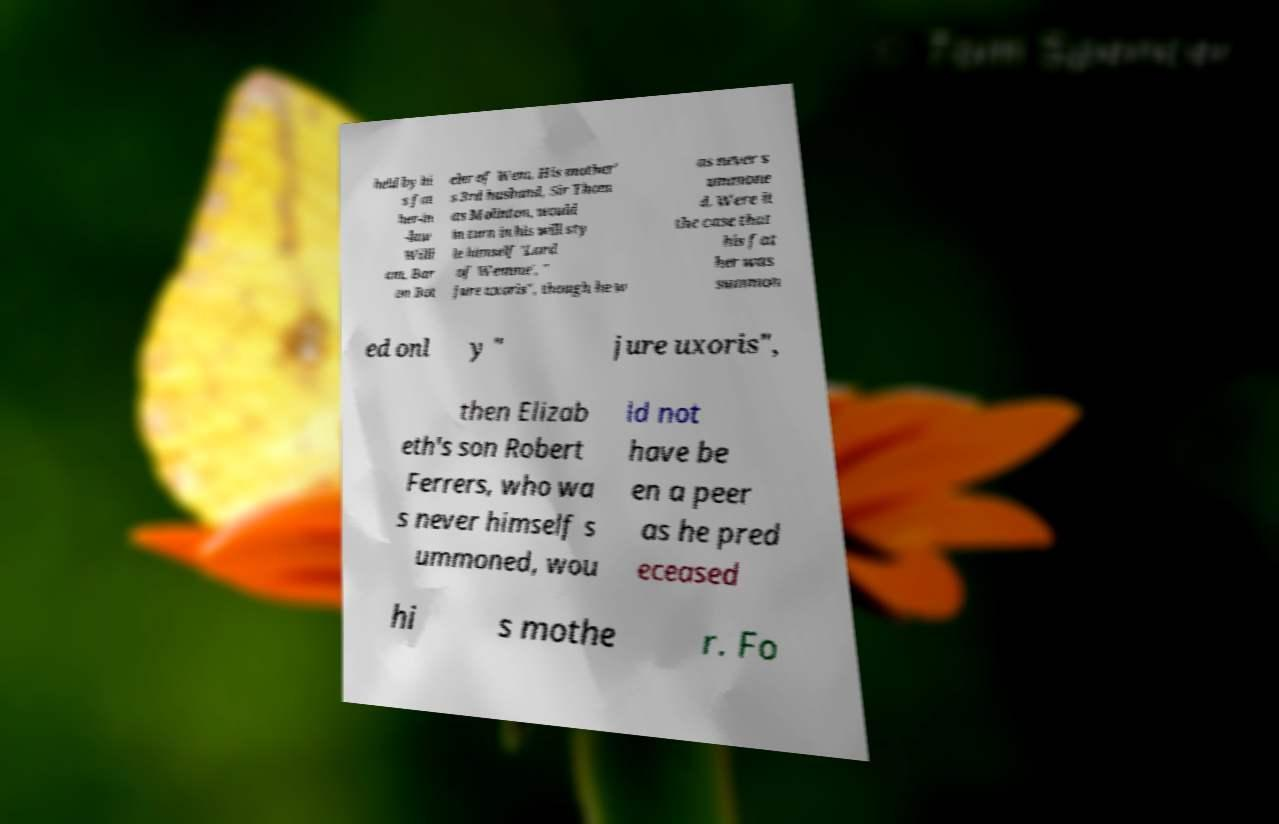I need the written content from this picture converted into text. Can you do that? held by hi s fat her-in -law Willi am, Bar on Bot eler of Wem. His mother' s 3rd husband, Sir Thom as Molinton, would in turn in his will sty le himself 'Lord of Wemme', " jure uxoris", though he w as never s ummone d. Were it the case that his fat her was summon ed onl y " jure uxoris", then Elizab eth's son Robert Ferrers, who wa s never himself s ummoned, wou ld not have be en a peer as he pred eceased hi s mothe r. Fo 